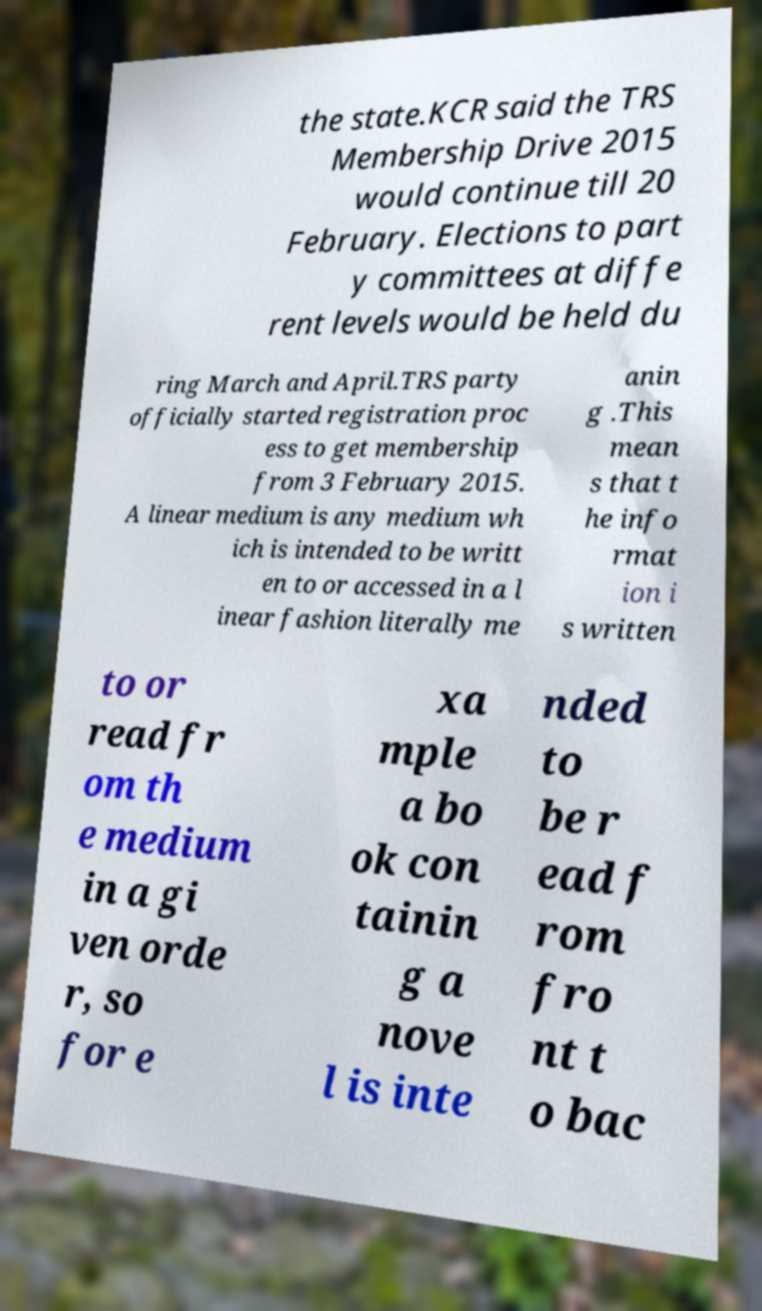Could you assist in decoding the text presented in this image and type it out clearly? the state.KCR said the TRS Membership Drive 2015 would continue till 20 February. Elections to part y committees at diffe rent levels would be held du ring March and April.TRS party officially started registration proc ess to get membership from 3 February 2015. A linear medium is any medium wh ich is intended to be writt en to or accessed in a l inear fashion literally me anin g .This mean s that t he info rmat ion i s written to or read fr om th e medium in a gi ven orde r, so for e xa mple a bo ok con tainin g a nove l is inte nded to be r ead f rom fro nt t o bac 